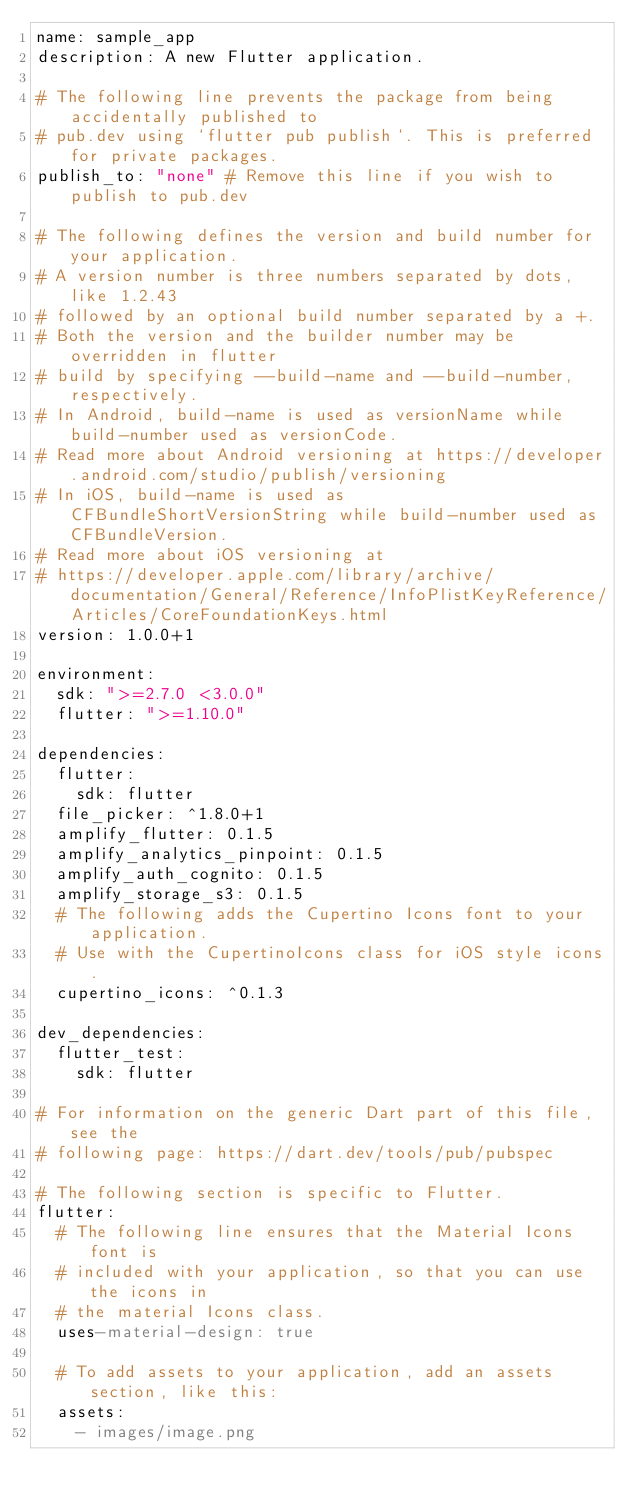Convert code to text. <code><loc_0><loc_0><loc_500><loc_500><_YAML_>name: sample_app
description: A new Flutter application.

# The following line prevents the package from being accidentally published to
# pub.dev using `flutter pub publish`. This is preferred for private packages.
publish_to: "none" # Remove this line if you wish to publish to pub.dev

# The following defines the version and build number for your application.
# A version number is three numbers separated by dots, like 1.2.43
# followed by an optional build number separated by a +.
# Both the version and the builder number may be overridden in flutter
# build by specifying --build-name and --build-number, respectively.
# In Android, build-name is used as versionName while build-number used as versionCode.
# Read more about Android versioning at https://developer.android.com/studio/publish/versioning
# In iOS, build-name is used as CFBundleShortVersionString while build-number used as CFBundleVersion.
# Read more about iOS versioning at
# https://developer.apple.com/library/archive/documentation/General/Reference/InfoPlistKeyReference/Articles/CoreFoundationKeys.html
version: 1.0.0+1

environment:
  sdk: ">=2.7.0 <3.0.0"
  flutter: ">=1.10.0"

dependencies:
  flutter:
    sdk: flutter
  file_picker: ^1.8.0+1
  amplify_flutter: 0.1.5
  amplify_analytics_pinpoint: 0.1.5
  amplify_auth_cognito: 0.1.5
  amplify_storage_s3: 0.1.5
  # The following adds the Cupertino Icons font to your application.
  # Use with the CupertinoIcons class for iOS style icons.
  cupertino_icons: ^0.1.3

dev_dependencies:
  flutter_test:
    sdk: flutter

# For information on the generic Dart part of this file, see the
# following page: https://dart.dev/tools/pub/pubspec

# The following section is specific to Flutter.
flutter:
  # The following line ensures that the Material Icons font is
  # included with your application, so that you can use the icons in
  # the material Icons class.
  uses-material-design: true

  # To add assets to your application, add an assets section, like this:
  assets:
    - images/image.png</code> 